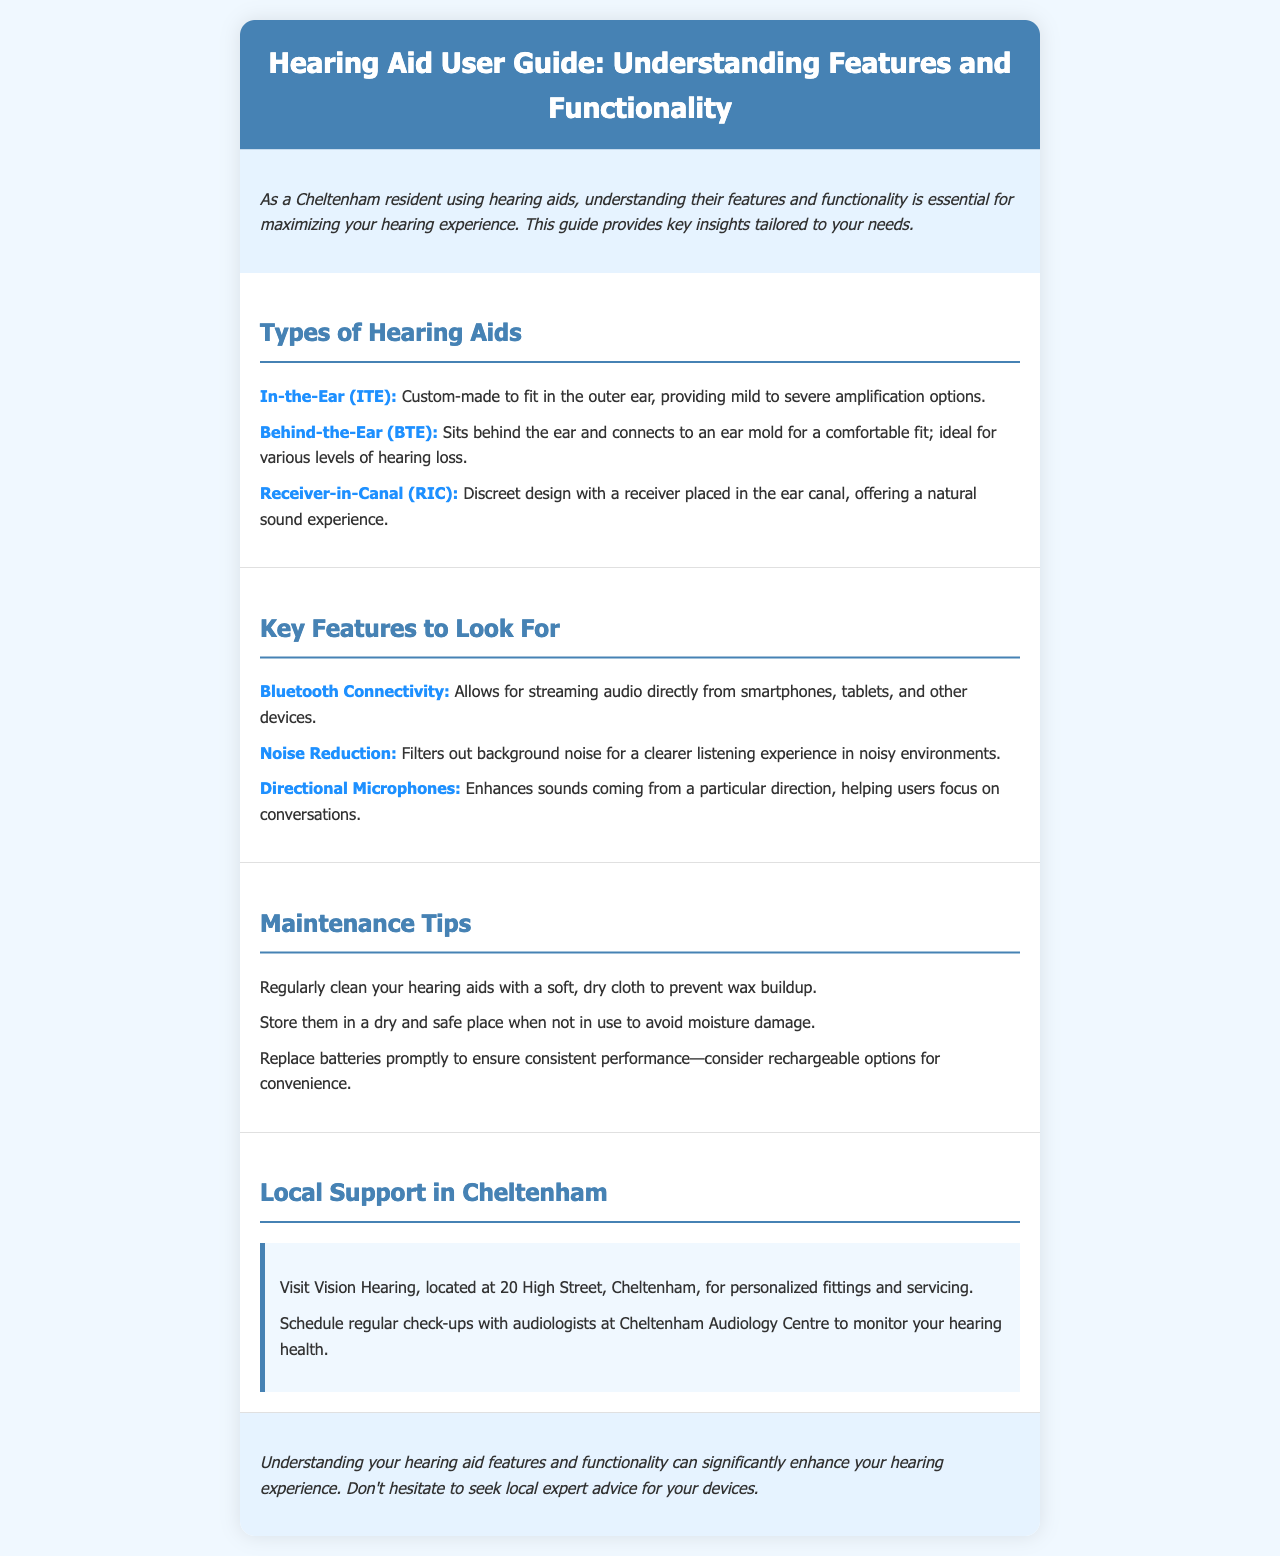What are the types of hearing aids mentioned? The document lists three types of hearing aids which are In-the-Ear (ITE), Behind-the-Ear (BTE), and Receiver-in-Canal (RIC).
Answer: ITE, BTE, RIC What feature allows streaming from devices? The document specifies that Bluetooth connectivity allows for streaming audio directly from smartphones, tablets, and other devices.
Answer: Bluetooth Connectivity How should hearing aids be cleaned? The document mentions cleaning hearing aids with a soft, dry cloth to prevent wax buildup as a maintenance tip.
Answer: Soft, dry cloth What is the address of the local support in Cheltenham? The document provides the address for Vision Hearing, which is located at 20 High Street, Cheltenham.
Answer: 20 High Street, Cheltenham What is a recommended maintenance tip for hearing aids? The document highlights replacing batteries promptly to ensure consistent performance.
Answer: Replace batteries promptly Which feature enhances sounds from a particular direction? The document states that directional microphones enhance sounds coming from a particular direction, helping users focus on conversations.
Answer: Directional Microphones What should be avoided to prevent moisture damage? According to the document, storing hearing aids in a dry and safe place when not in use helps avoid moisture damage.
Answer: Dry and safe place What type of service does Cheltenham Audiology Centre provide? The document indicates that Cheltenham Audiology Centre offers regular check-ups to monitor hearing health.
Answer: Regular check-ups How can the understanding of hearing aid features impact a user's experience? The document concludes that understanding hearing aid features can significantly enhance the hearing experience.
Answer: Significantly enhance hearing experience 